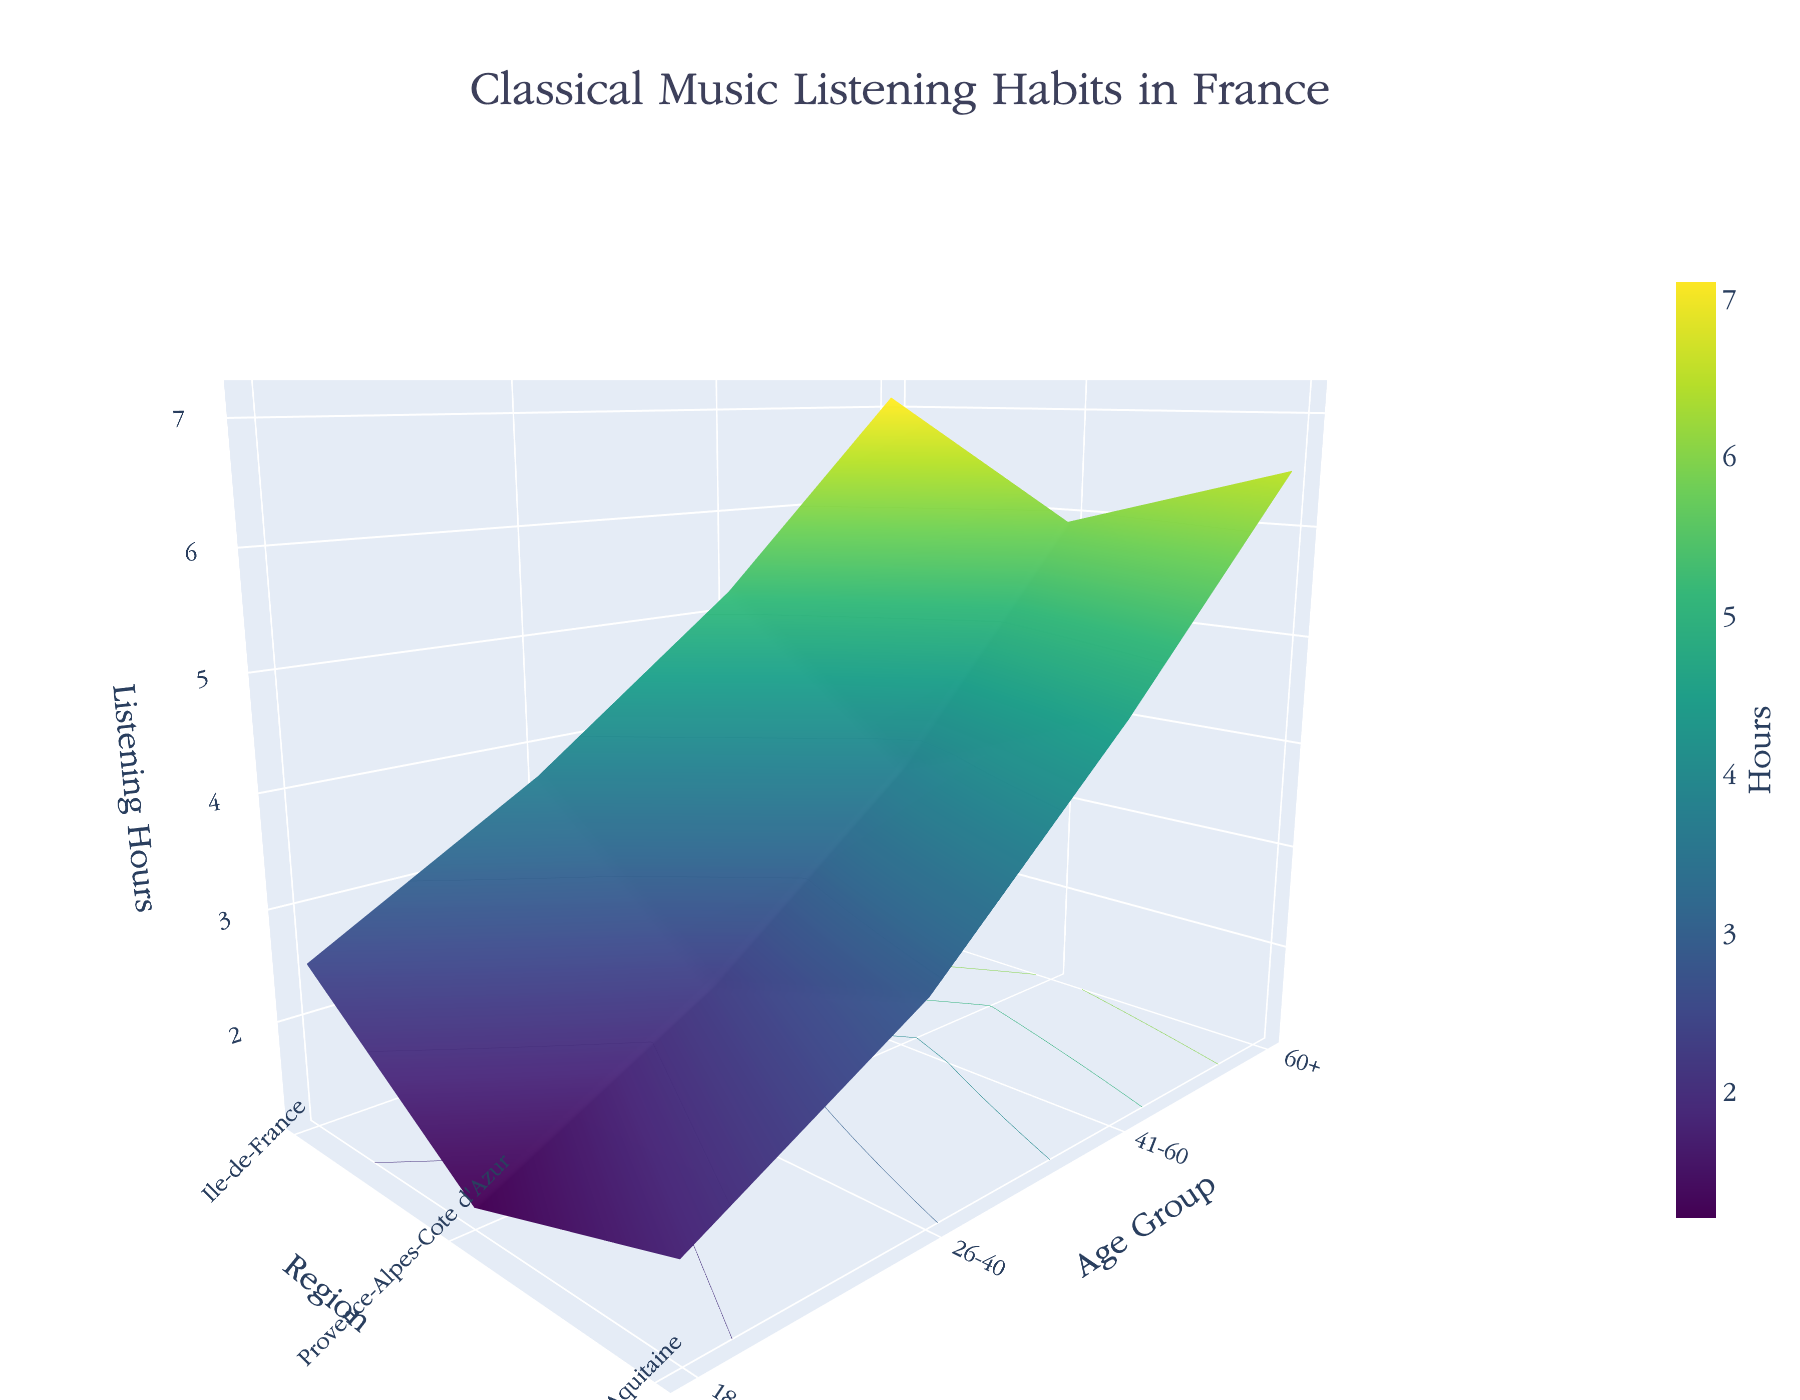What is the title of the figure? The title is usually displayed prominently at the top of the figure. In this case, it reads "Classical Music Listening Habits in France."
Answer: Classical Music Listening Habits in France Which axis represents the age groups? By examining the labels along the axes, the age groups are listed along the y-axis.
Answer: y-axis What is the listening hour for the 60+ age group in Ile-de-France? Locate the age group "60+" on the y-axis, then find the Ile-de-France region on the x-axis. The corresponding height (z-value) on the surface plot gives the listening hours.
Answer: 7.1 Which geographical region has the highest average listening hours across all age groups? Calculate the average listening hours for each region by summing the hours for all age groups within each region and dividing by the number of age groups. The region with the highest average is Ile-de-France.
Answer: Ile-de-France How does the listening habit of the 18-25 age group in Provence-Alpes-Cote d'Azur compare to the 26-40 age group in the same region? Find the listening hours for 18-25 and 26-40 age groups in Provence-Alpes-Cote d'Azur. Compare 1.8 (18-25) and 2.9 (26-40).
Answer: The 26-40 age group listens more (2.9 vs. 1.8 hours) What is the difference in listening hours between the 41-60 and 60+ age groups in Nouvelle-Aquitaine? Find the listening hours for 41-60 and 60+ age groups in Nouvelle-Aquitaine. Subtract 5.9 (60+) by 3.8 (41-60).
Answer: 2.1 Which age group in Ile-de-France shows the greatest increase in listening hours compared to the previous age group? Compare the differences in listening hours between consecutive age groups (18-25 to 26-40, 26-40 to 41-60, 41-60 to 60+) in Ile-de-France. The increase from 41-60 to 60+ is the greatest.
Answer: 41-60 to 60+ How does the color scheme in this plot help in interpreting the data? The gradient of colors represents varying listening hours. Darker shades indicate lower listening hours, while lighter shades indicate higher listening hours, making it easier to visualize the differences.
Answer: It shows varying listening hours Which region shows a consistent increase in listening hours with age? Observe the listening hours in each region across the age groups. Ile-de-France shows a consistent increase in listening hours as age increases.
Answer: Ile-de-France 